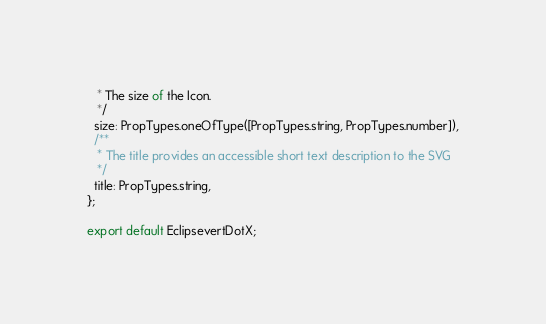Convert code to text. <code><loc_0><loc_0><loc_500><loc_500><_JavaScript_>   * The size of the Icon.
   */
  size: PropTypes.oneOfType([PropTypes.string, PropTypes.number]),
  /**
   * The title provides an accessible short text description to the SVG
   */
  title: PropTypes.string,
};

export default EclipsevertDotX;
</code> 